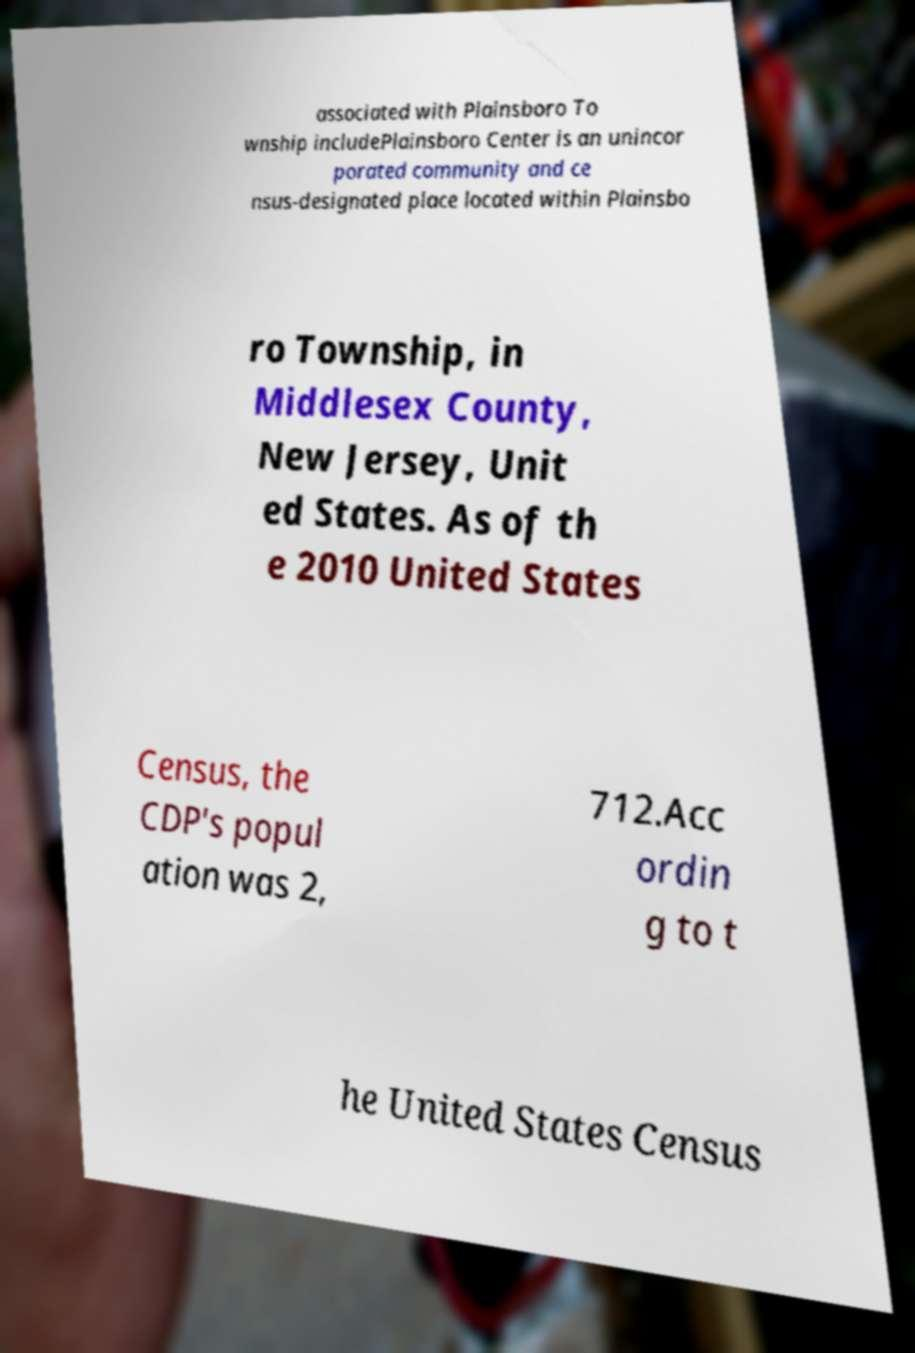For documentation purposes, I need the text within this image transcribed. Could you provide that? associated with Plainsboro To wnship includePlainsboro Center is an unincor porated community and ce nsus-designated place located within Plainsbo ro Township, in Middlesex County, New Jersey, Unit ed States. As of th e 2010 United States Census, the CDP's popul ation was 2, 712.Acc ordin g to t he United States Census 